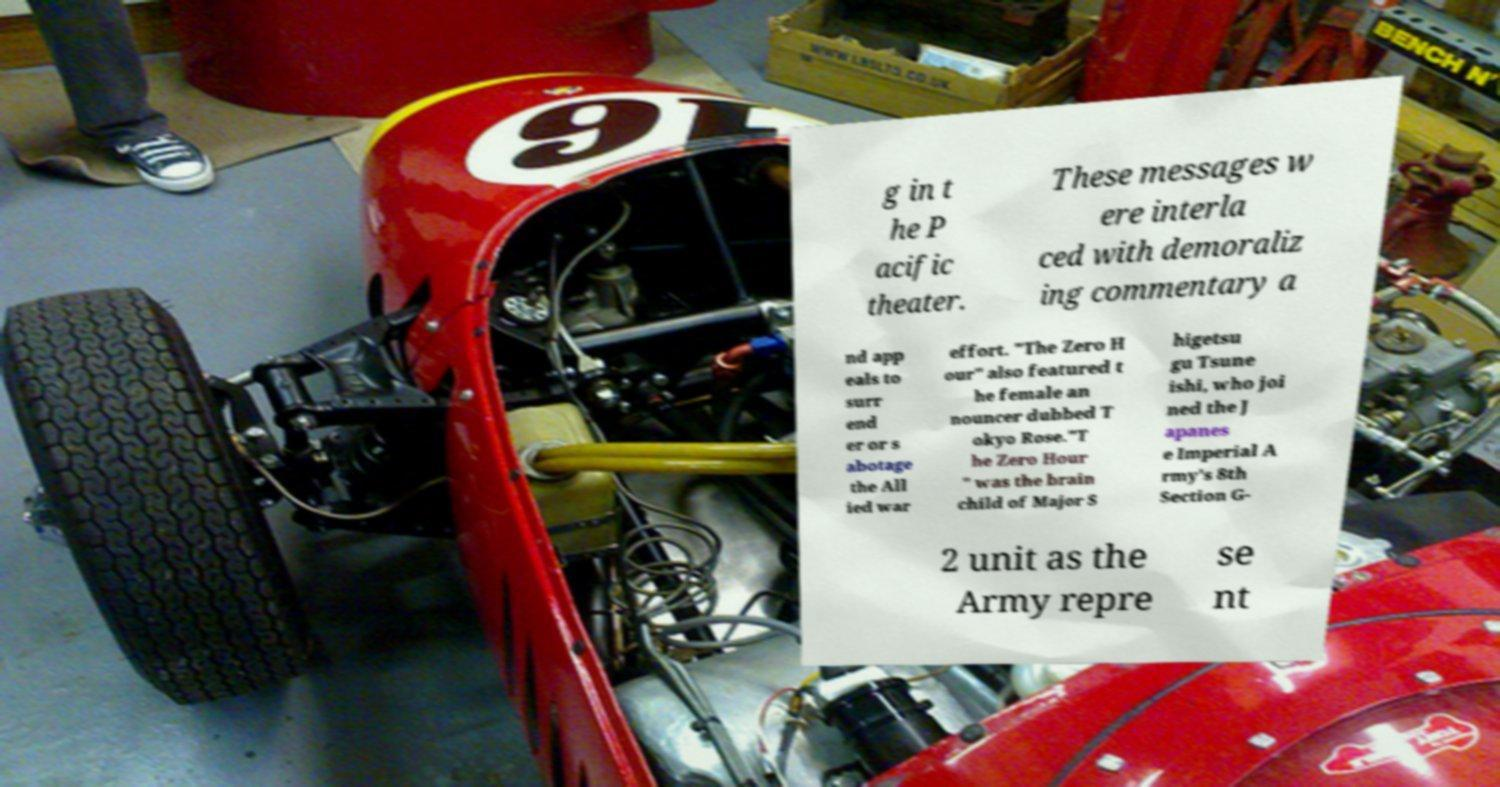Please identify and transcribe the text found in this image. g in t he P acific theater. These messages w ere interla ced with demoraliz ing commentary a nd app eals to surr end er or s abotage the All ied war effort. "The Zero H our" also featured t he female an nouncer dubbed T okyo Rose."T he Zero Hour " was the brain child of Major S higetsu gu Tsune ishi, who joi ned the J apanes e Imperial A rmy's 8th Section G- 2 unit as the Army repre se nt 